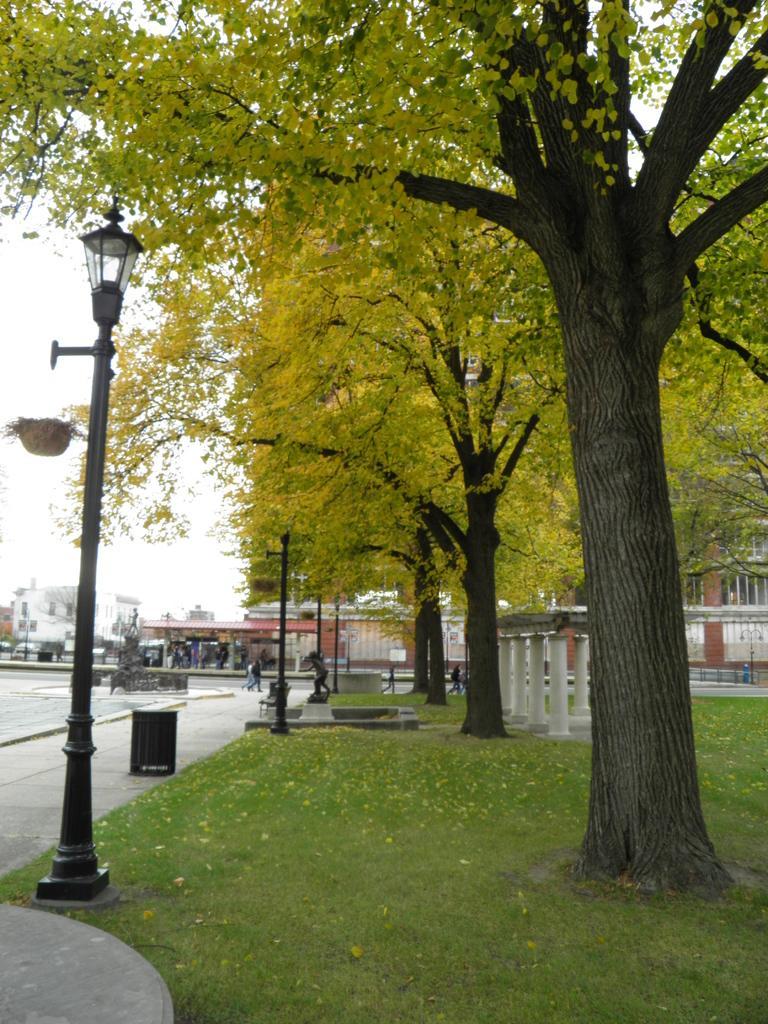Can you describe this image briefly? In this image there is grassland, beside that there are light poles, pavement, in the background there are trees, buildings and the sky. 